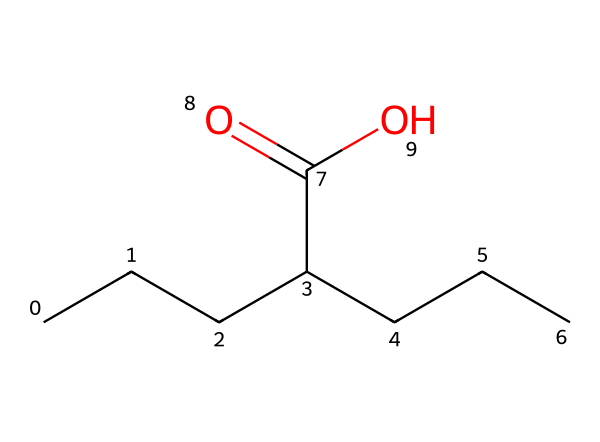What is the name of this chemical? The chemical can be identified by its structure as valproic acid, which is a common treatment for epilepsy.
Answer: valproic acid How many carbon atoms are in this molecule? By examining the structure, there are 8 carbon atoms present in total, indicated by each vertex of the carbon chain.
Answer: 8 What kind of functional group is present in this structure? The structure shows a carboxylic acid functional group, which is identified by the presence of the -COOH at one end of the carbon chain.
Answer: carboxylic acid How many hydrogen atoms are bonded to the carbon atoms? Counting the hydrogen atoms, there are 16 hydrogen atoms bonded to the carbon atoms in the structure according to standard bonding rules for carbon.
Answer: 16 What is the molecular formula of this compound? The molecular formula can be derived from the number of each type of atom in the structure, calculated as C8H16O2.
Answer: C8H16O2 Does this compound exhibit acidic properties? The presence of the carboxylic acid functional group typically imparts acidic properties to the compound, allowing it to donate a proton.
Answer: Yes 